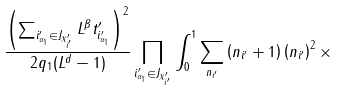Convert formula to latex. <formula><loc_0><loc_0><loc_500><loc_500>\frac { \left ( \sum _ { i ^ { \prime } _ { \alpha _ { 1 } } \in J _ { X ^ { \prime } _ { i ^ { \prime } } } } L ^ { \beta } t ^ { \prime } _ { i ^ { \prime } _ { \alpha _ { 1 } } } \right ) ^ { 2 } } { 2 q _ { 1 } ( L ^ { d } - 1 ) } \prod _ { i ^ { \prime } _ { \alpha _ { 1 } } \in J _ { X ^ { \prime } _ { i ^ { \prime } } } } \int ^ { 1 } _ { 0 } \sum _ { n _ { i ^ { \prime } } } \left ( n _ { i ^ { \prime } } + 1 \right ) \left ( n _ { i ^ { \prime } } \right ) ^ { 2 } \times</formula> 